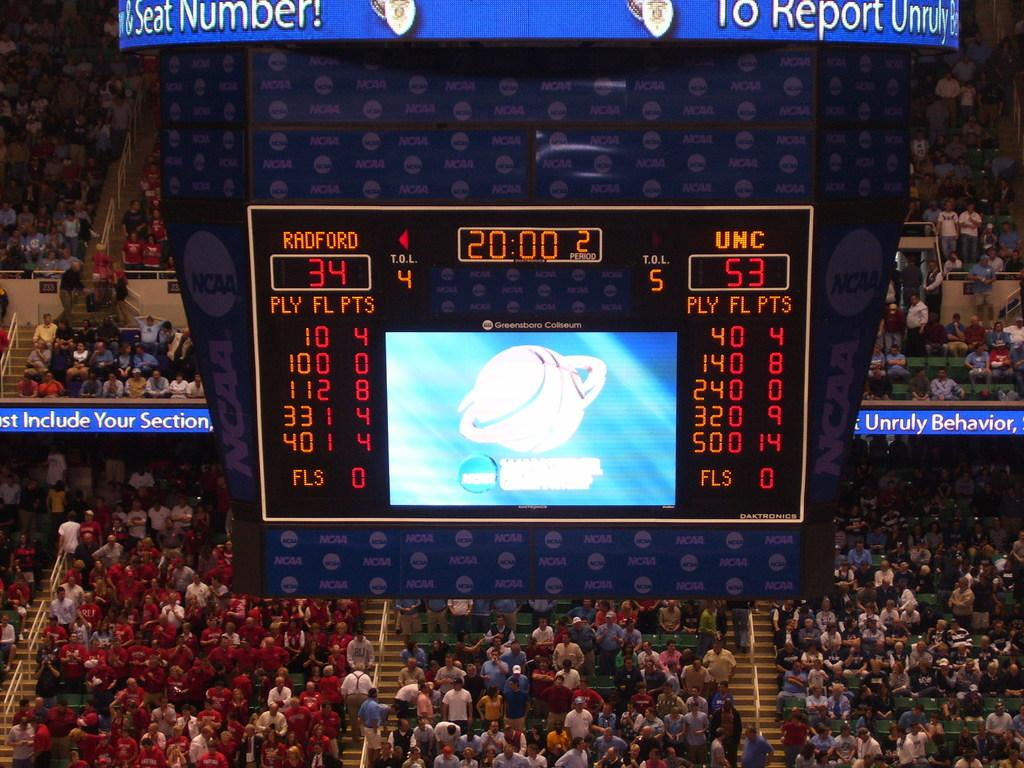Provide a one-sentence caption for the provided image. A scoreboard reveals that the game is at the 20:00 mark at 34 to 53. 